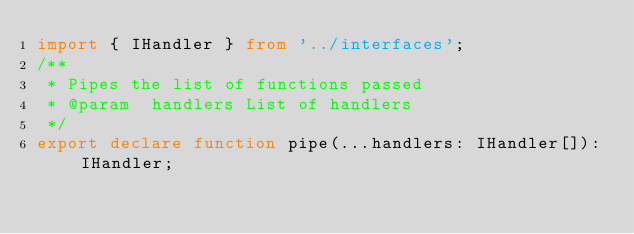<code> <loc_0><loc_0><loc_500><loc_500><_TypeScript_>import { IHandler } from '../interfaces';
/**
 * Pipes the list of functions passed
 * @param  handlers List of handlers
 */
export declare function pipe(...handlers: IHandler[]): IHandler;
</code> 